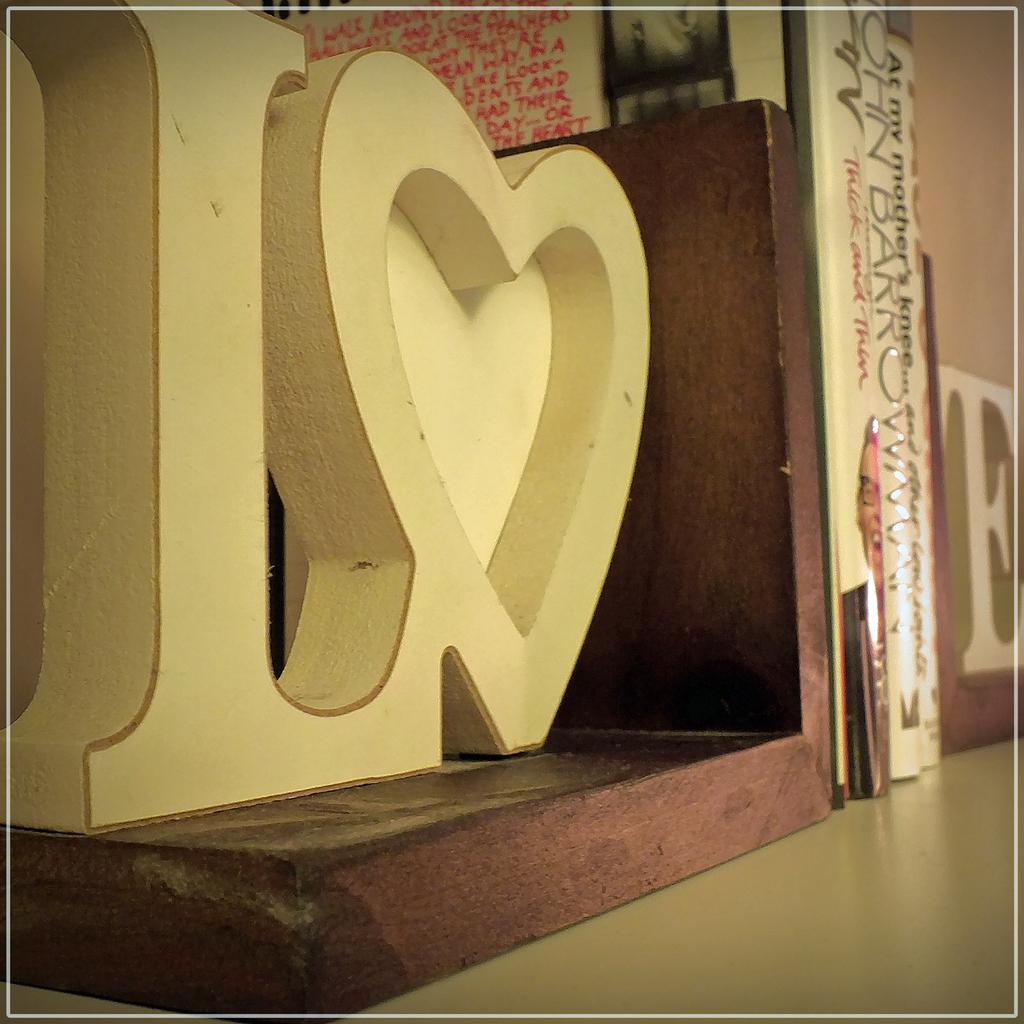<image>
Offer a succinct explanation of the picture presented. The letter L beside a heart sits on a shelf with books beside it. 